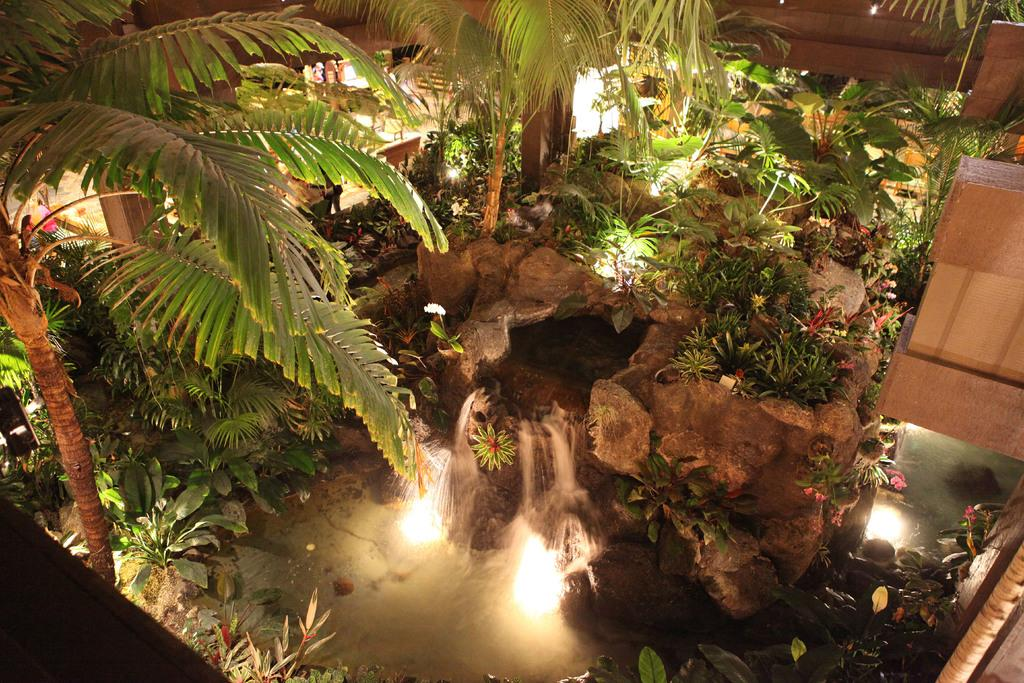What type of natural elements can be seen in the image? There are trees and plants visible in the image. What else can be seen in the image besides trees and plants? There is water visible in the image. Are there any artificial elements present in the image? Yes, there are lights in the image. What is a notable feature of the water in the image? There is a waterfall in the image. What type of account is being discussed in the image? There is no account being discussed in the image; it features natural elements and a waterfall. What color is the person's hair in the image? There are no people present in the image, so hair color cannot be determined. 